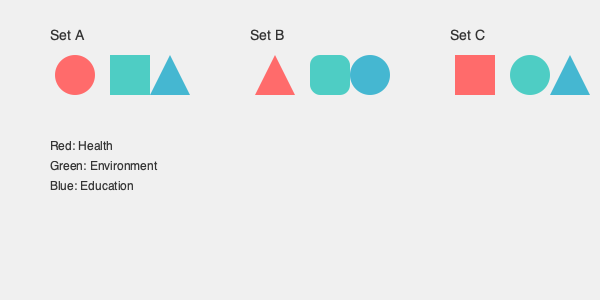As a project manager for a non-profit organization, you're designing a React application to showcase various charitable causes. Which set of icons would be most effective in representing health, environment, and education causes while ensuring a user-friendly interface? To determine the most effective icon set for representing charitable causes in a user-friendly React application, we need to consider the following factors:

1. Visual clarity: Icons should be easily recognizable and distinguishable from one another.
2. Consistency: The style of icons within a set should be uniform.
3. Relevance: Icons should relate to the causes they represent.
4. Simplicity: Simple designs are easier to understand and implement in a React application.

Let's analyze each set:

Set A:
- Health (red circle): Simple, but not specifically related to health.
- Environment (green square): Simple, but not specifically related to the environment.
- Education (blue triangle): Simple, but not specifically related to education.
Consistency is good, but relevance is low.

Set B:
- Health (red triangle): The triangle shape could represent a warning sign, which might be associated with health concerns.
- Environment (green rounded square): The rounded edges could represent organic shapes found in nature.
- Education (blue circle): The circle could represent completeness or a learning cycle.
This set has better relevance and maintains consistency in style.

Set C:
- Health (red square): Not specifically related to health.
- Environment (green circle): The circle could represent the planet or cyclical nature of environmental processes.
- Education (blue triangle): Could represent growth or progress in learning.
This set has mixed relevance and less consistency in style.

Considering these factors, Set B provides the best balance of visual clarity, consistency, relevance, and simplicity. The shapes in Set B are more likely to be associated with their respective causes while maintaining a cohesive style, making it easier for users to understand and navigate the React application.
Answer: Set B 